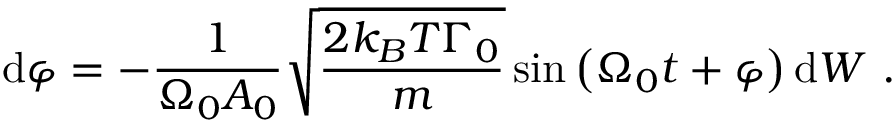Convert formula to latex. <formula><loc_0><loc_0><loc_500><loc_500>d \varphi = - \frac { 1 } { \Omega _ { 0 } A _ { 0 } } \sqrt { \frac { 2 k _ { B } T \Gamma _ { 0 } } { m } } \sin \left ( \Omega _ { 0 } t + \varphi \right ) d W .</formula> 